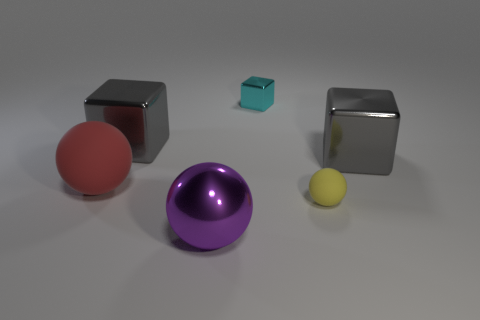Add 3 small blue things. How many objects exist? 9 Subtract all red rubber spheres. How many spheres are left? 2 Subtract all purple balls. How many balls are left? 2 Subtract 3 blocks. How many blocks are left? 0 Subtract all blue blocks. Subtract all gray spheres. How many blocks are left? 3 Subtract all blue cylinders. How many gray cubes are left? 2 Subtract all small cyan things. Subtract all blue matte cylinders. How many objects are left? 5 Add 4 large gray blocks. How many large gray blocks are left? 6 Add 2 small metallic objects. How many small metallic objects exist? 3 Subtract 0 green blocks. How many objects are left? 6 